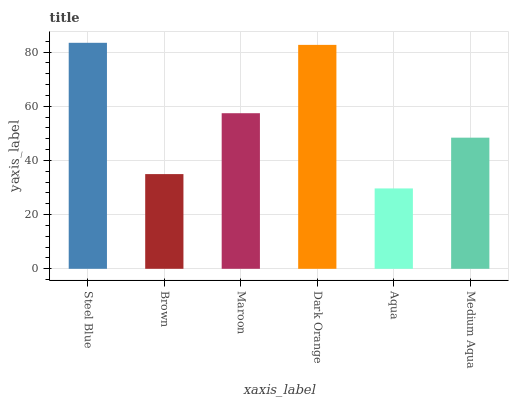Is Aqua the minimum?
Answer yes or no. Yes. Is Steel Blue the maximum?
Answer yes or no. Yes. Is Brown the minimum?
Answer yes or no. No. Is Brown the maximum?
Answer yes or no. No. Is Steel Blue greater than Brown?
Answer yes or no. Yes. Is Brown less than Steel Blue?
Answer yes or no. Yes. Is Brown greater than Steel Blue?
Answer yes or no. No. Is Steel Blue less than Brown?
Answer yes or no. No. Is Maroon the high median?
Answer yes or no. Yes. Is Medium Aqua the low median?
Answer yes or no. Yes. Is Dark Orange the high median?
Answer yes or no. No. Is Brown the low median?
Answer yes or no. No. 